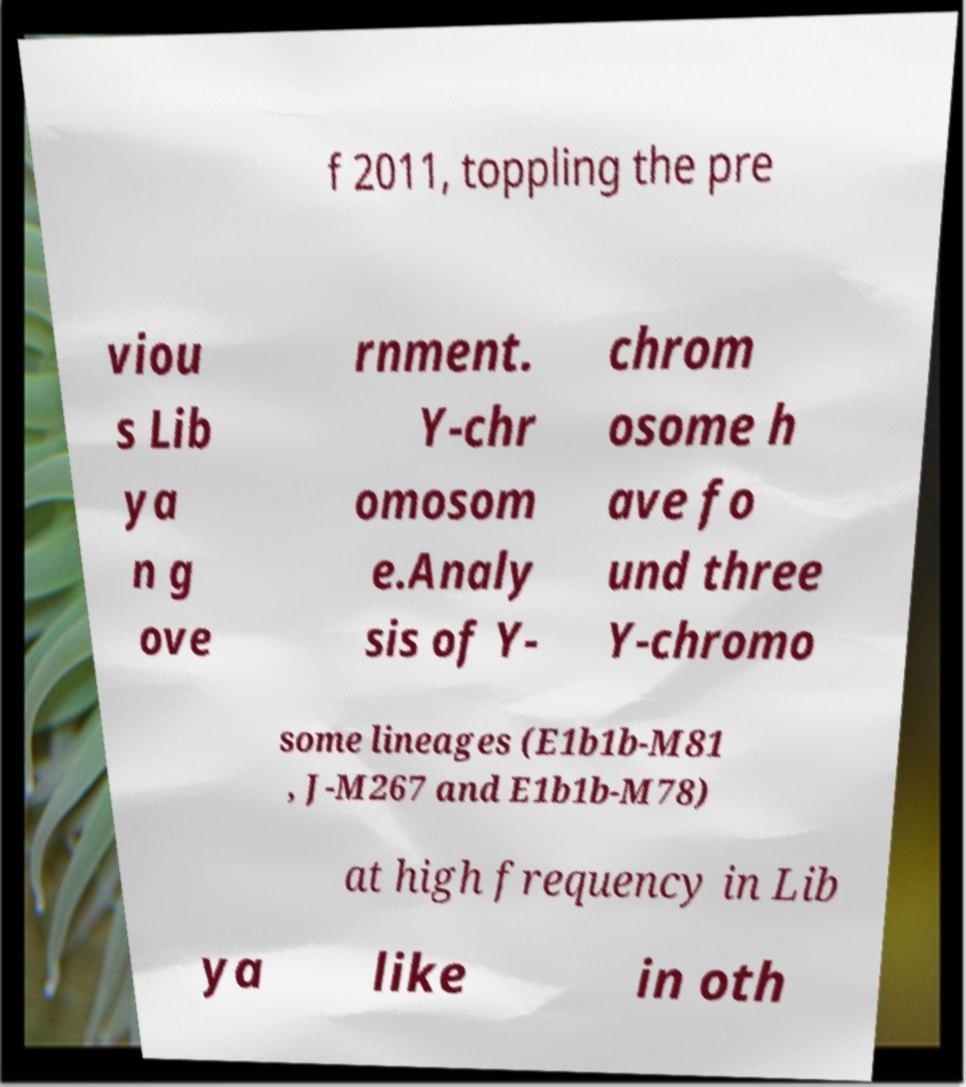What messages or text are displayed in this image? I need them in a readable, typed format. f 2011, toppling the pre viou s Lib ya n g ove rnment. Y-chr omosom e.Analy sis of Y- chrom osome h ave fo und three Y-chromo some lineages (E1b1b-M81 , J-M267 and E1b1b-M78) at high frequency in Lib ya like in oth 